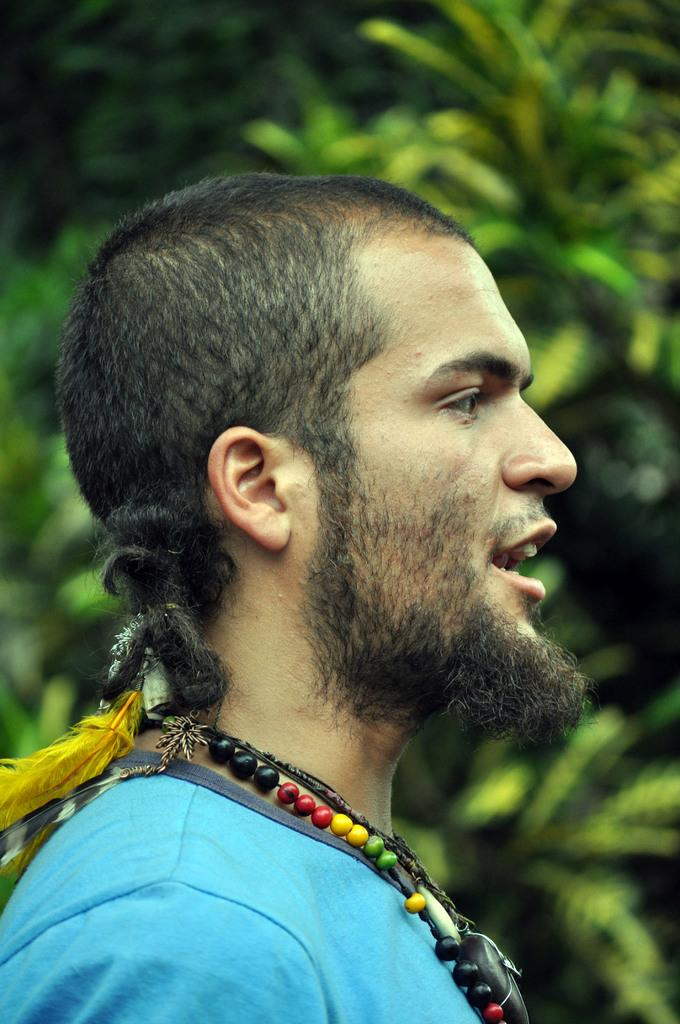Who is the main subject in the image? There is a man in the image. What is the man's position in the image? The man is standing in the front. What is the man's facial expression or direction of gaze? The man is looking straight. How would you describe the background of the image? There is a blurred background in the image. What type of vegetation can be seen in the background? Green leaves are visible in the background. What type of soda is the man holding in the image? There is no soda present in the image; the man is not holding any object. 